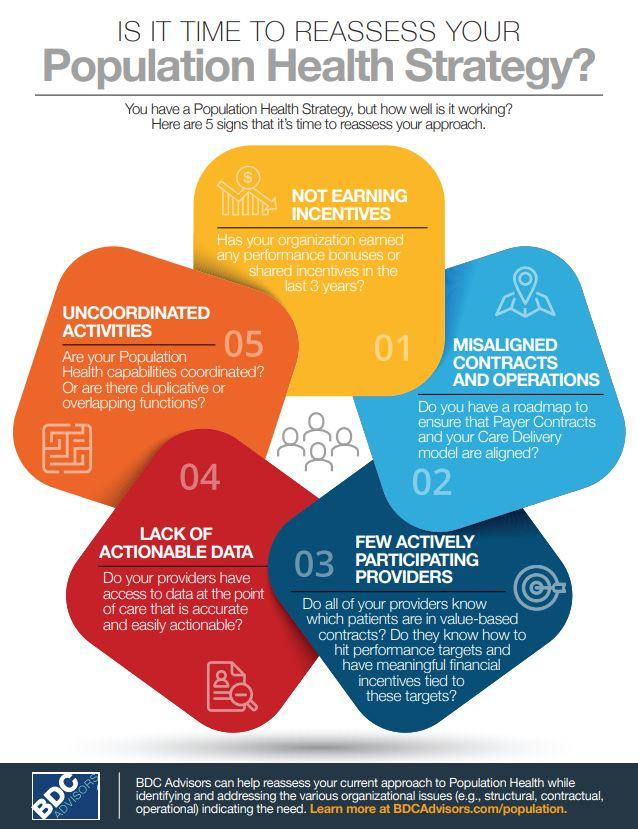Mention a couple of crucial points in this snapshot. Upon discovering duplicative or overlapping functions and uncoordinated activities within the population health strategy, it is imperative to reassess and restructure the strategy to ensure efficient and effective outcomes. The stated reason on the red card is a lack of actionable data. It is a reason for reassessing your population health strategy to not earning incentives. 